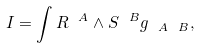<formula> <loc_0><loc_0><loc_500><loc_500>I = \int R ^ { \ A } \wedge S ^ { \ B } g _ { \ A \ B } ,</formula> 